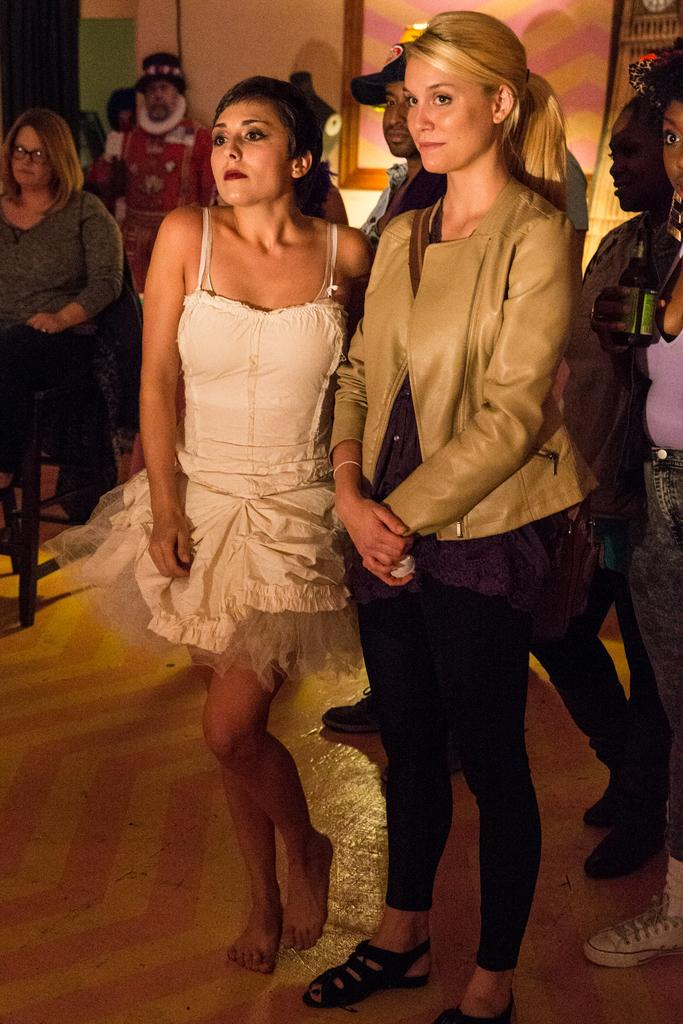How many ladies are in the center of the image? There are two ladies standing in the center of the image. What can be seen in the background of the image? There are people and a wall in the background of the image. What is visible at the bottom of the image? There is a floor visible at the bottom of the image. What type of day is depicted in the image? The provided facts do not mention any information about the day or weather, so it cannot be determined from the image. 